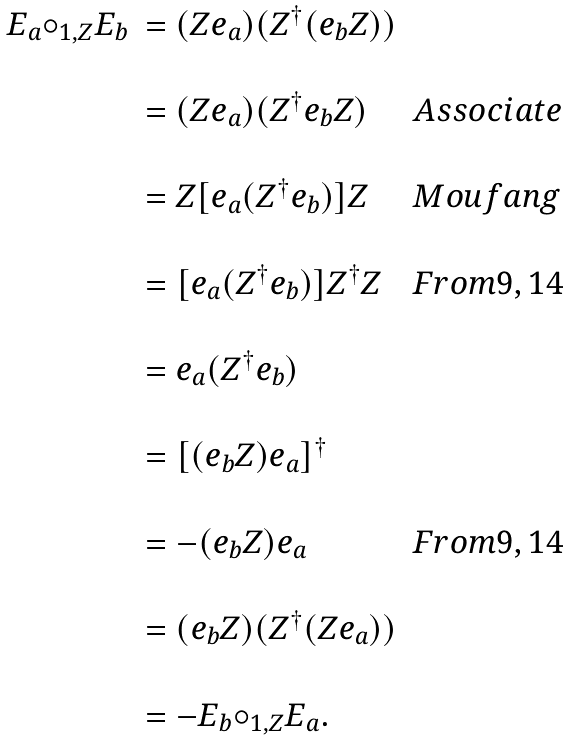<formula> <loc_0><loc_0><loc_500><loc_500>\begin{array} { c l l } E _ { a } { \circ _ { 1 , Z } } E _ { b } & = ( Z e _ { a } ) ( Z ^ { \dagger } ( e _ { b } Z ) ) & \\ \\ & = ( Z e _ { a } ) ( Z ^ { \dagger } e _ { b } Z ) & A s s o c i a t e \\ \\ & = Z [ e _ { a } ( Z ^ { \dagger } e _ { b } ) ] Z & M o u f a n g \\ \\ & = [ e _ { a } ( Z ^ { \dagger } e _ { b } ) ] Z ^ { \dagger } Z & F r o m 9 , 1 4 \\ \\ & = e _ { a } ( Z ^ { \dagger } e _ { b } ) & \\ \\ & = [ ( e _ { b } Z ) e _ { a } ] ^ { \dagger } & \\ \\ & = - ( e _ { b } Z ) e _ { a } & F r o m 9 , 1 4 \\ \\ & = ( e _ { b } Z ) ( Z ^ { \dagger } ( Z e _ { a } ) ) & \\ \\ & = - E _ { b } { \circ _ { 1 , Z } } E _ { a } . & \\ \end{array}</formula> 